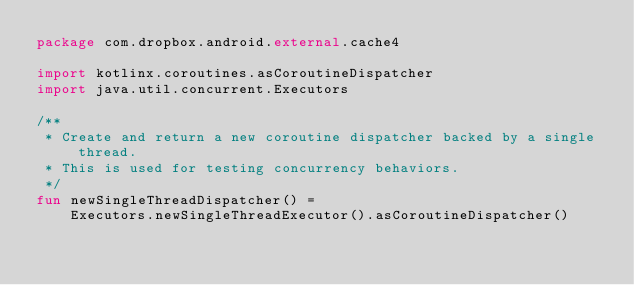Convert code to text. <code><loc_0><loc_0><loc_500><loc_500><_Kotlin_>package com.dropbox.android.external.cache4

import kotlinx.coroutines.asCoroutineDispatcher
import java.util.concurrent.Executors

/**
 * Create and return a new coroutine dispatcher backed by a single thread.
 * This is used for testing concurrency behaviors.
 */
fun newSingleThreadDispatcher() =
    Executors.newSingleThreadExecutor().asCoroutineDispatcher()
</code> 